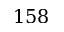<formula> <loc_0><loc_0><loc_500><loc_500>1 5 8</formula> 